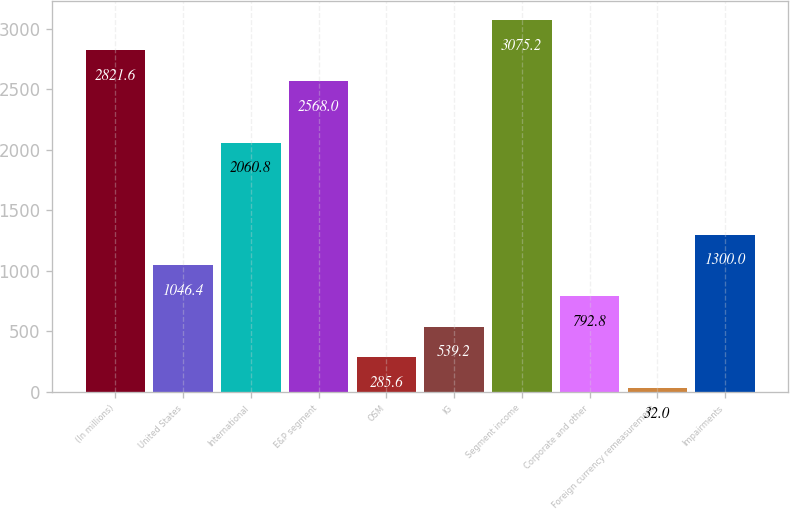Convert chart to OTSL. <chart><loc_0><loc_0><loc_500><loc_500><bar_chart><fcel>(In millions)<fcel>United States<fcel>International<fcel>E&P segment<fcel>OSM<fcel>IG<fcel>Segment income<fcel>Corporate and other<fcel>Foreign currency remeasurement<fcel>Impairments<nl><fcel>2821.6<fcel>1046.4<fcel>2060.8<fcel>2568<fcel>285.6<fcel>539.2<fcel>3075.2<fcel>792.8<fcel>32<fcel>1300<nl></chart> 